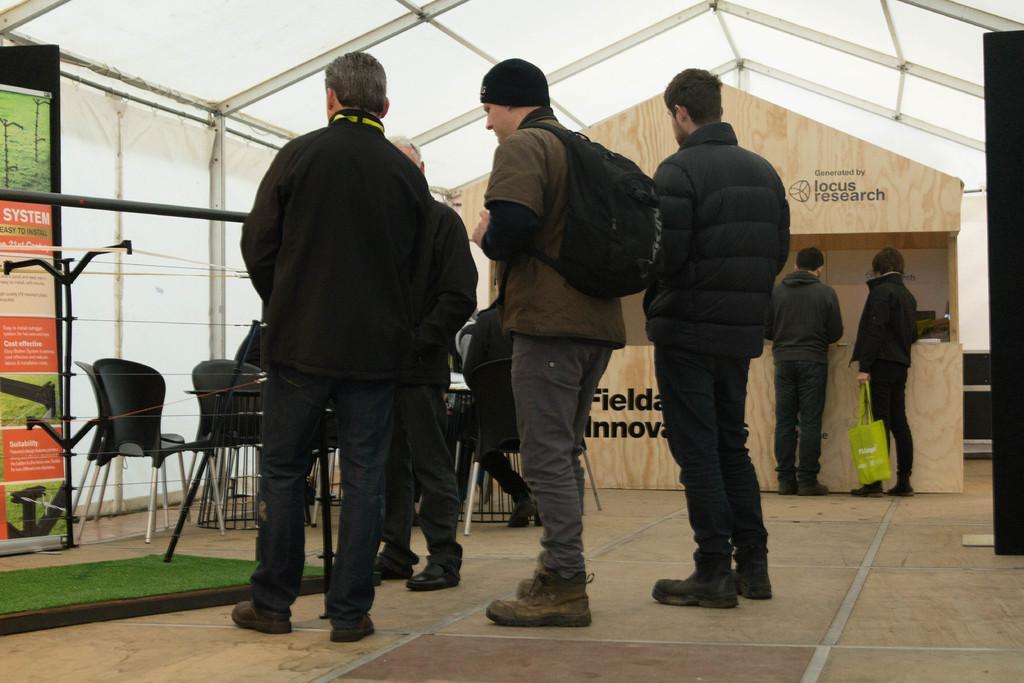Could you give a brief overview of what you see in this image? In this image we can see these people wearing jackets and shoes are standing on the wooden floor. Here we can see the mat, banners, fence, chairs and table, two persons standing near the wooden desk on which we can see some text. In the background, we can see the tent. 